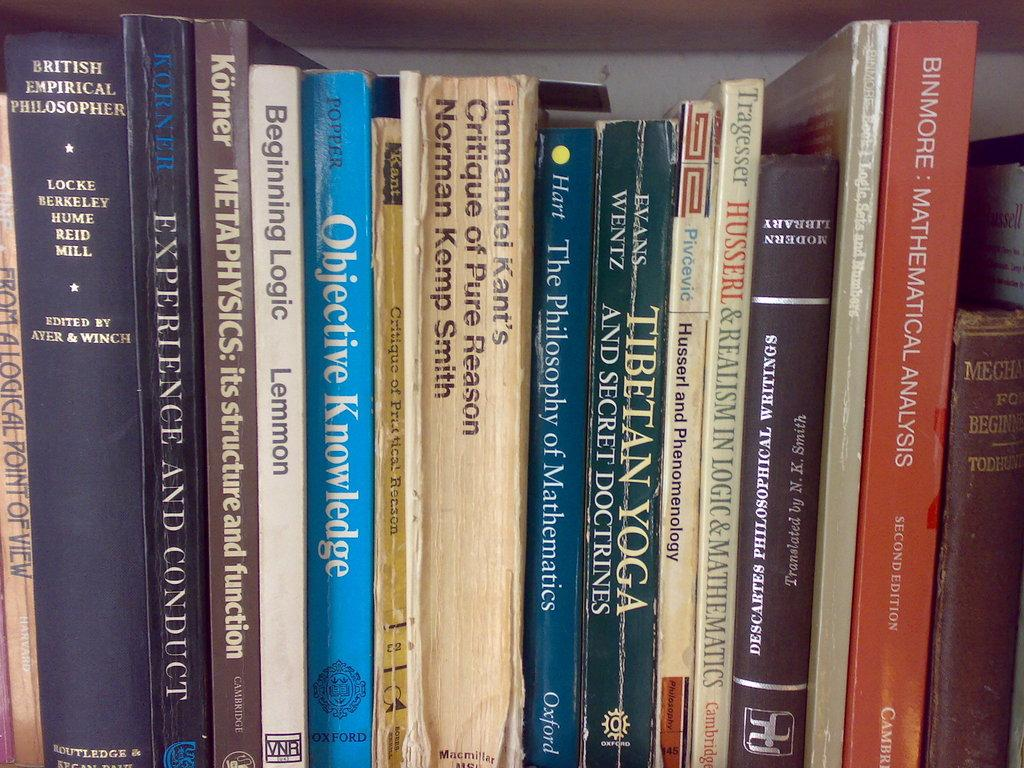Provide a one-sentence caption for the provided image. A stack of books on a shelf including the book Objective Knowledge. 